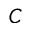Convert formula to latex. <formula><loc_0><loc_0><loc_500><loc_500>C</formula> 